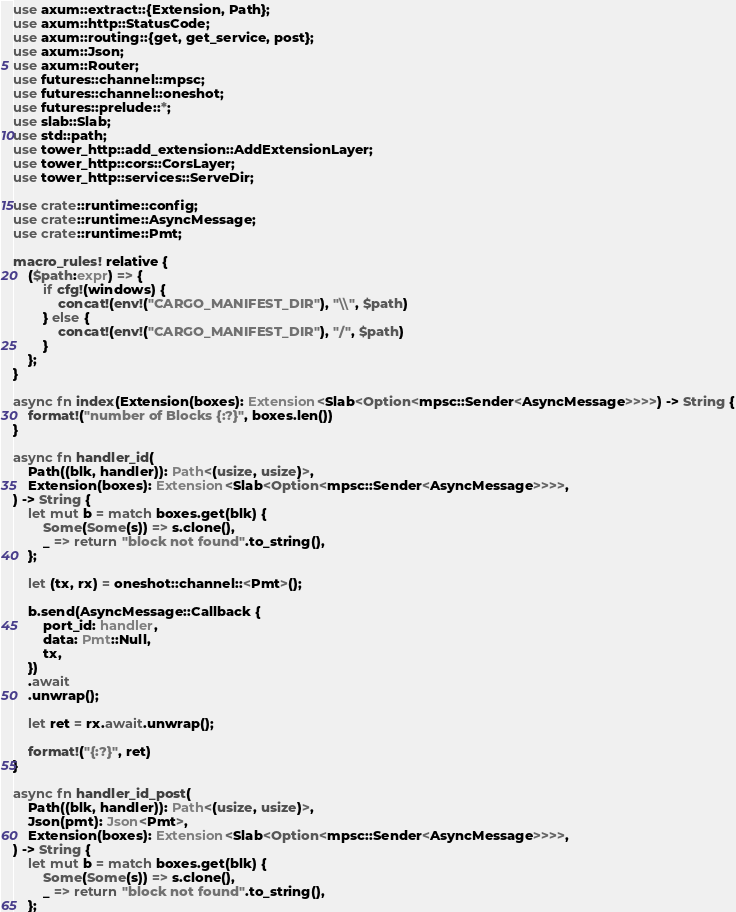Convert code to text. <code><loc_0><loc_0><loc_500><loc_500><_Rust_>use axum::extract::{Extension, Path};
use axum::http::StatusCode;
use axum::routing::{get, get_service, post};
use axum::Json;
use axum::Router;
use futures::channel::mpsc;
use futures::channel::oneshot;
use futures::prelude::*;
use slab::Slab;
use std::path;
use tower_http::add_extension::AddExtensionLayer;
use tower_http::cors::CorsLayer;
use tower_http::services::ServeDir;

use crate::runtime::config;
use crate::runtime::AsyncMessage;
use crate::runtime::Pmt;

macro_rules! relative {
    ($path:expr) => {
        if cfg!(windows) {
            concat!(env!("CARGO_MANIFEST_DIR"), "\\", $path)
        } else {
            concat!(env!("CARGO_MANIFEST_DIR"), "/", $path)
        }
    };
}

async fn index(Extension(boxes): Extension<Slab<Option<mpsc::Sender<AsyncMessage>>>>) -> String {
    format!("number of Blocks {:?}", boxes.len())
}

async fn handler_id(
    Path((blk, handler)): Path<(usize, usize)>,
    Extension(boxes): Extension<Slab<Option<mpsc::Sender<AsyncMessage>>>>,
) -> String {
    let mut b = match boxes.get(blk) {
        Some(Some(s)) => s.clone(),
        _ => return "block not found".to_string(),
    };

    let (tx, rx) = oneshot::channel::<Pmt>();

    b.send(AsyncMessage::Callback {
        port_id: handler,
        data: Pmt::Null,
        tx,
    })
    .await
    .unwrap();

    let ret = rx.await.unwrap();

    format!("{:?}", ret)
}

async fn handler_id_post(
    Path((blk, handler)): Path<(usize, usize)>,
    Json(pmt): Json<Pmt>,
    Extension(boxes): Extension<Slab<Option<mpsc::Sender<AsyncMessage>>>>,
) -> String {
    let mut b = match boxes.get(blk) {
        Some(Some(s)) => s.clone(),
        _ => return "block not found".to_string(),
    };
</code> 